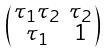Convert formula to latex. <formula><loc_0><loc_0><loc_500><loc_500>\begin{psmallmatrix} \tau _ { 1 } \tau _ { 2 } & \tau _ { 2 } \\ \tau _ { 1 } & 1 \end{psmallmatrix}</formula> 